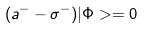Convert formula to latex. <formula><loc_0><loc_0><loc_500><loc_500>( a ^ { - } - \sigma ^ { - } ) | \Phi > = 0</formula> 